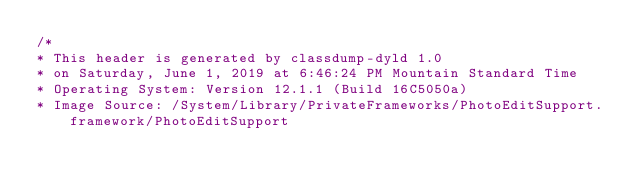Convert code to text. <code><loc_0><loc_0><loc_500><loc_500><_C_>/*
* This header is generated by classdump-dyld 1.0
* on Saturday, June 1, 2019 at 6:46:24 PM Mountain Standard Time
* Operating System: Version 12.1.1 (Build 16C5050a)
* Image Source: /System/Library/PrivateFrameworks/PhotoEditSupport.framework/PhotoEditSupport</code> 